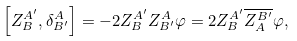<formula> <loc_0><loc_0><loc_500><loc_500>\left [ Z ^ { A ^ { \prime } } _ { B } , \delta _ { B ^ { \prime } } ^ { A } \right ] = - 2 Z ^ { A ^ { \prime } } _ { B } Z _ { B ^ { \prime } } ^ { A } \varphi = 2 Z ^ { A ^ { \prime } } _ { B } \overline { Z ^ { B ^ { \prime } } _ { A } } \varphi ,</formula> 